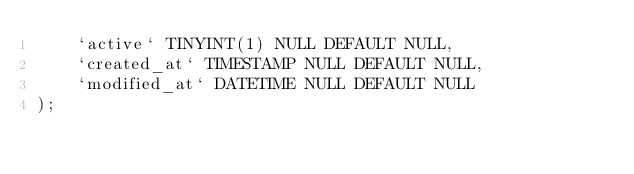Convert code to text. <code><loc_0><loc_0><loc_500><loc_500><_SQL_>	`active` TINYINT(1) NULL DEFAULT NULL,
	`created_at` TIMESTAMP NULL DEFAULT NULL,
	`modified_at` DATETIME NULL DEFAULT NULL
);</code> 